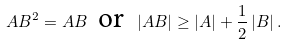<formula> <loc_0><loc_0><loc_500><loc_500>A B ^ { 2 } = A B \, \text { or } \, \left | A B \right | \geq \left | A \right | + \frac { 1 } { 2 } \left | B \right | .</formula> 